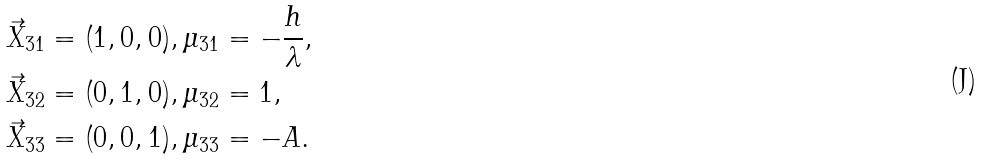Convert formula to latex. <formula><loc_0><loc_0><loc_500><loc_500>\vec { X } _ { 3 1 } & = ( 1 , 0 , 0 ) , \mu _ { 3 1 } = - \frac { h } { \lambda } , \\ \vec { X } _ { 3 2 } & = ( 0 , 1 , 0 ) , \mu _ { 3 2 } = 1 , \\ \vec { X } _ { 3 3 } & = ( 0 , 0 , 1 ) , \mu _ { 3 3 } = - A .</formula> 